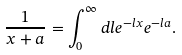Convert formula to latex. <formula><loc_0><loc_0><loc_500><loc_500>\frac { 1 } { x + a } = \int _ { 0 } ^ { \infty } { d l e ^ { - l x } e ^ { - l a } } .</formula> 